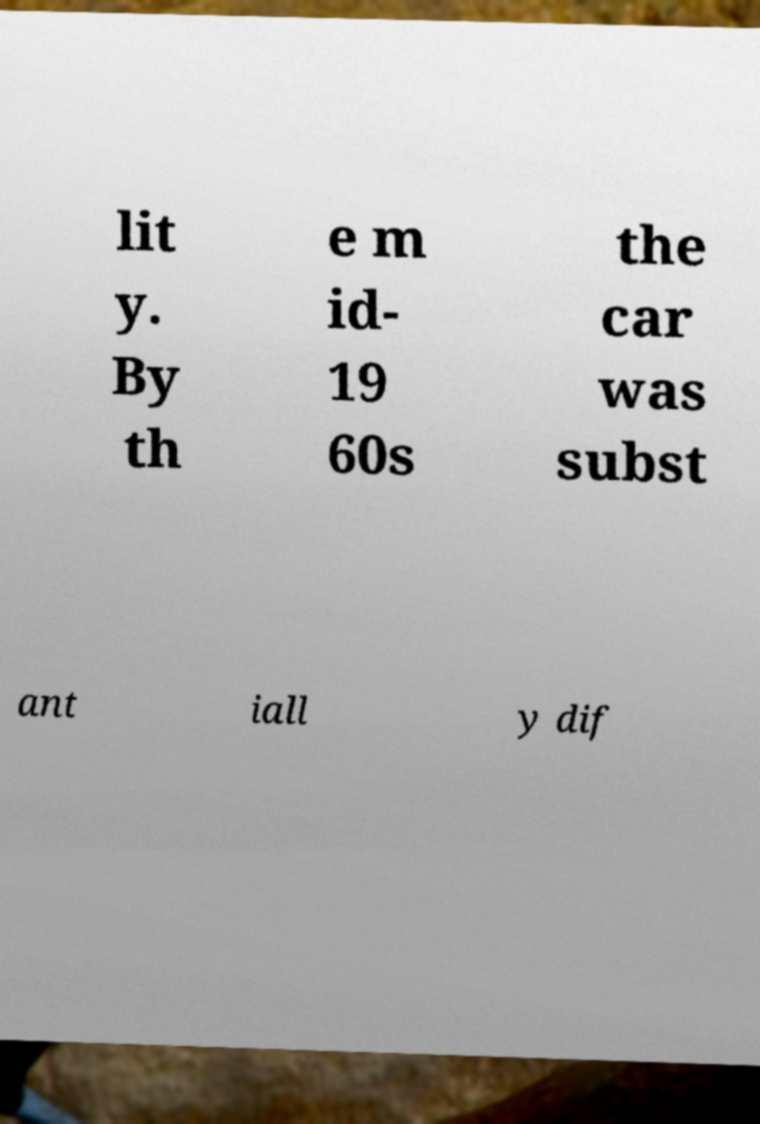Can you read and provide the text displayed in the image?This photo seems to have some interesting text. Can you extract and type it out for me? lit y. By th e m id- 19 60s the car was subst ant iall y dif 